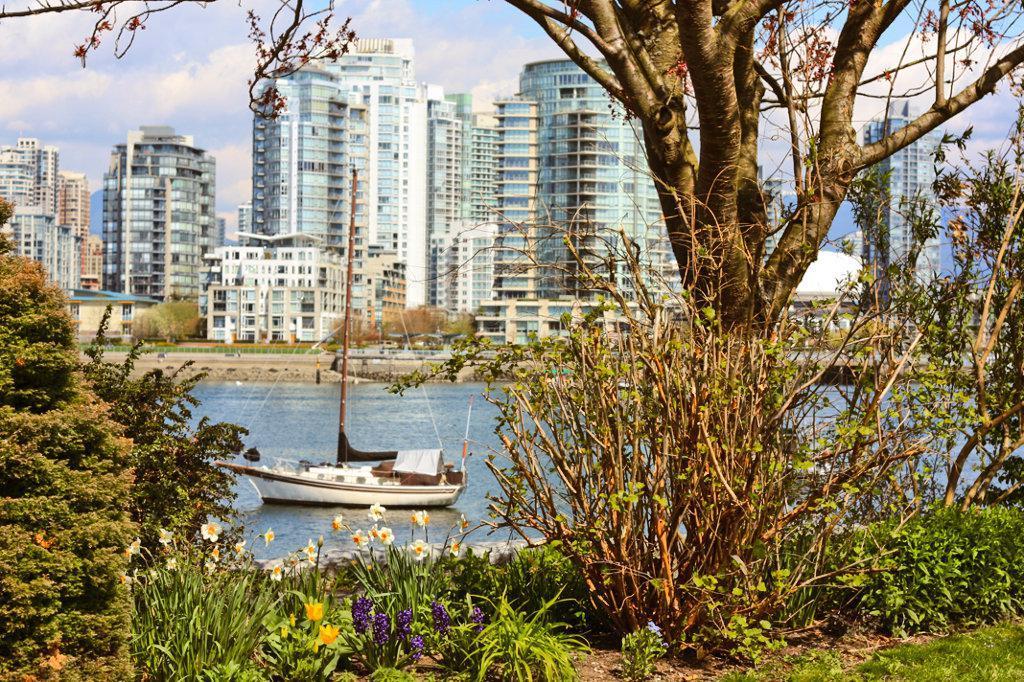In one or two sentences, can you explain what this image depicts? In this picture we can see few flowers, trees and a boat on the water, in the background we can find few buildings and clouds. 